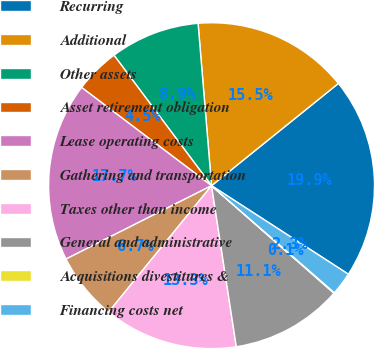Convert chart. <chart><loc_0><loc_0><loc_500><loc_500><pie_chart><fcel>Recurring<fcel>Additional<fcel>Other assets<fcel>Asset retirement obligation<fcel>Lease operating costs<fcel>Gathering and transportation<fcel>Taxes other than income<fcel>General and administrative<fcel>Acquisitions divestitures &<fcel>Financing costs net<nl><fcel>19.94%<fcel>15.52%<fcel>8.9%<fcel>4.48%<fcel>17.73%<fcel>6.69%<fcel>13.31%<fcel>11.1%<fcel>0.06%<fcel>2.27%<nl></chart> 